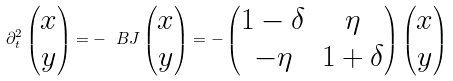<formula> <loc_0><loc_0><loc_500><loc_500>\partial _ { t } ^ { 2 } \begin{pmatrix} x \\ y \end{pmatrix} = - \ B J \begin{pmatrix} x \\ y \end{pmatrix} = - \begin{pmatrix} 1 - \delta & \eta \\ - \eta & 1 + \delta \end{pmatrix} \begin{pmatrix} x \\ y \end{pmatrix}</formula> 